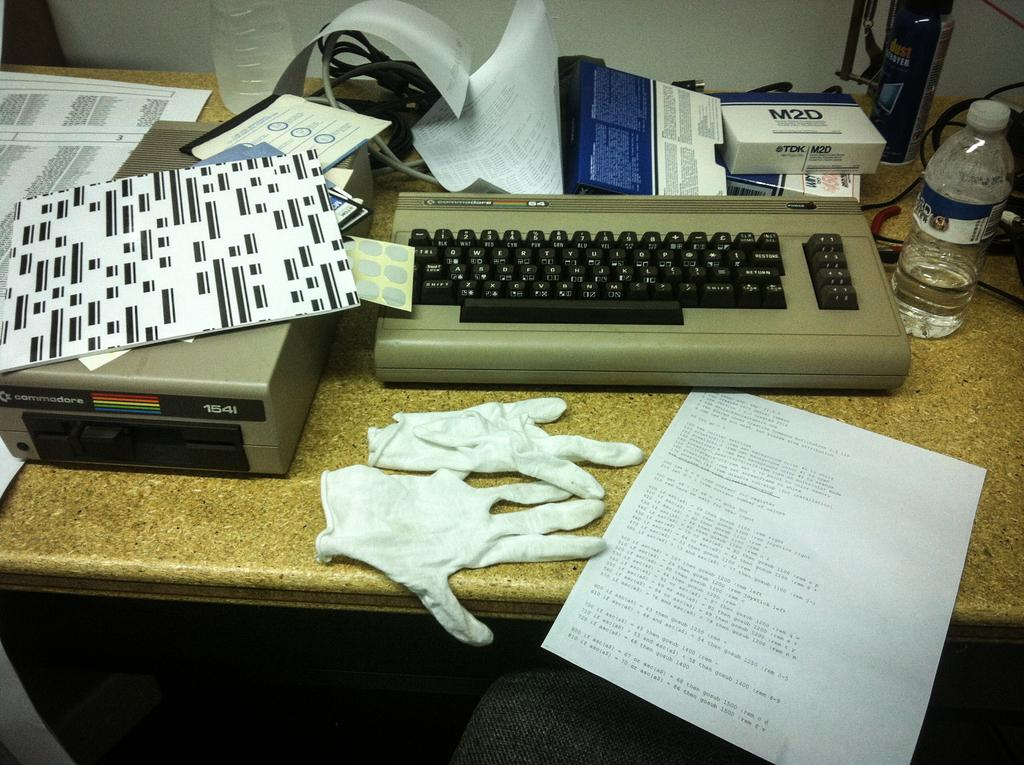<image>
Present a compact description of the photo's key features. A blue and white box sits above the keyboard with M2D written on it. 